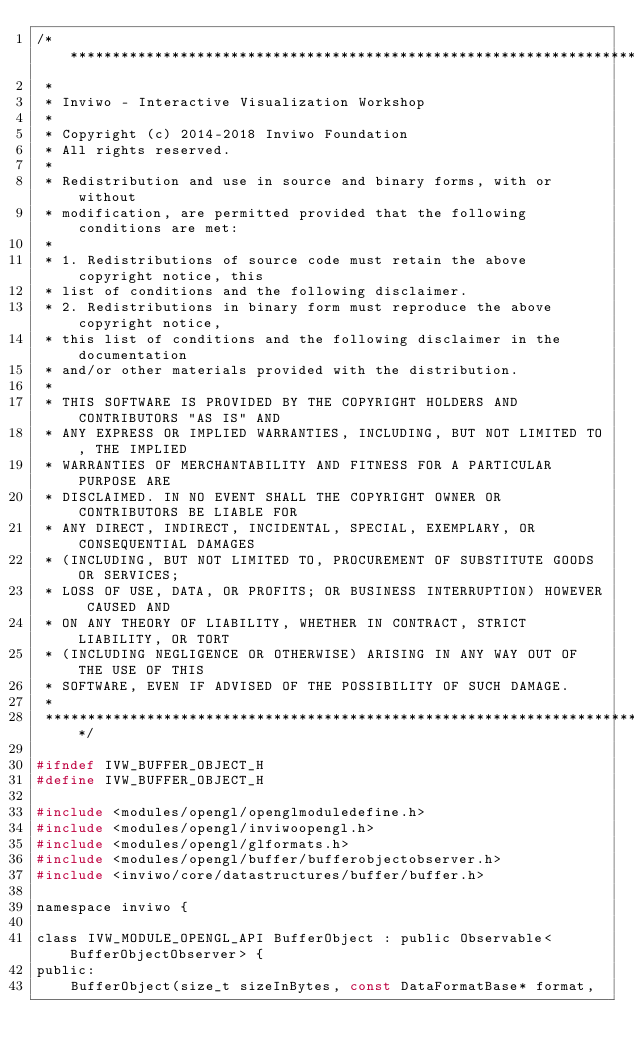<code> <loc_0><loc_0><loc_500><loc_500><_C_>/*********************************************************************************
 *
 * Inviwo - Interactive Visualization Workshop
 *
 * Copyright (c) 2014-2018 Inviwo Foundation
 * All rights reserved.
 *
 * Redistribution and use in source and binary forms, with or without
 * modification, are permitted provided that the following conditions are met:
 *
 * 1. Redistributions of source code must retain the above copyright notice, this
 * list of conditions and the following disclaimer.
 * 2. Redistributions in binary form must reproduce the above copyright notice,
 * this list of conditions and the following disclaimer in the documentation
 * and/or other materials provided with the distribution.
 *
 * THIS SOFTWARE IS PROVIDED BY THE COPYRIGHT HOLDERS AND CONTRIBUTORS "AS IS" AND
 * ANY EXPRESS OR IMPLIED WARRANTIES, INCLUDING, BUT NOT LIMITED TO, THE IMPLIED
 * WARRANTIES OF MERCHANTABILITY AND FITNESS FOR A PARTICULAR PURPOSE ARE
 * DISCLAIMED. IN NO EVENT SHALL THE COPYRIGHT OWNER OR CONTRIBUTORS BE LIABLE FOR
 * ANY DIRECT, INDIRECT, INCIDENTAL, SPECIAL, EXEMPLARY, OR CONSEQUENTIAL DAMAGES
 * (INCLUDING, BUT NOT LIMITED TO, PROCUREMENT OF SUBSTITUTE GOODS OR SERVICES;
 * LOSS OF USE, DATA, OR PROFITS; OR BUSINESS INTERRUPTION) HOWEVER CAUSED AND
 * ON ANY THEORY OF LIABILITY, WHETHER IN CONTRACT, STRICT LIABILITY, OR TORT
 * (INCLUDING NEGLIGENCE OR OTHERWISE) ARISING IN ANY WAY OUT OF THE USE OF THIS
 * SOFTWARE, EVEN IF ADVISED OF THE POSSIBILITY OF SUCH DAMAGE.
 *
 *********************************************************************************/

#ifndef IVW_BUFFER_OBJECT_H
#define IVW_BUFFER_OBJECT_H

#include <modules/opengl/openglmoduledefine.h>
#include <modules/opengl/inviwoopengl.h>
#include <modules/opengl/glformats.h>
#include <modules/opengl/buffer/bufferobjectobserver.h>
#include <inviwo/core/datastructures/buffer/buffer.h>

namespace inviwo {

class IVW_MODULE_OPENGL_API BufferObject : public Observable<BufferObjectObserver> {
public:
    BufferObject(size_t sizeInBytes, const DataFormatBase* format,</code> 